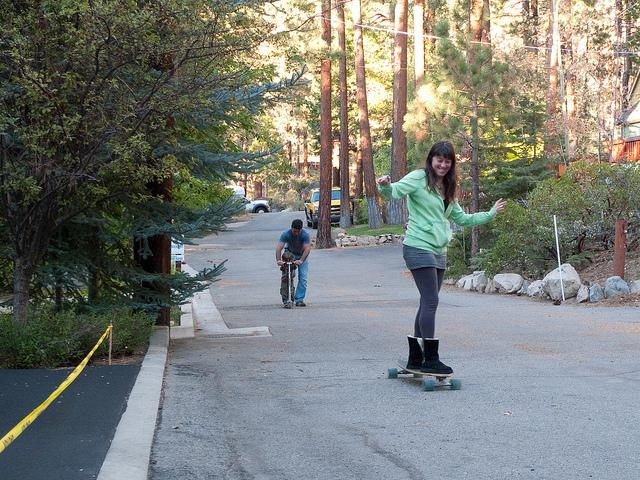What is the Man teaching the child? scooter riding 